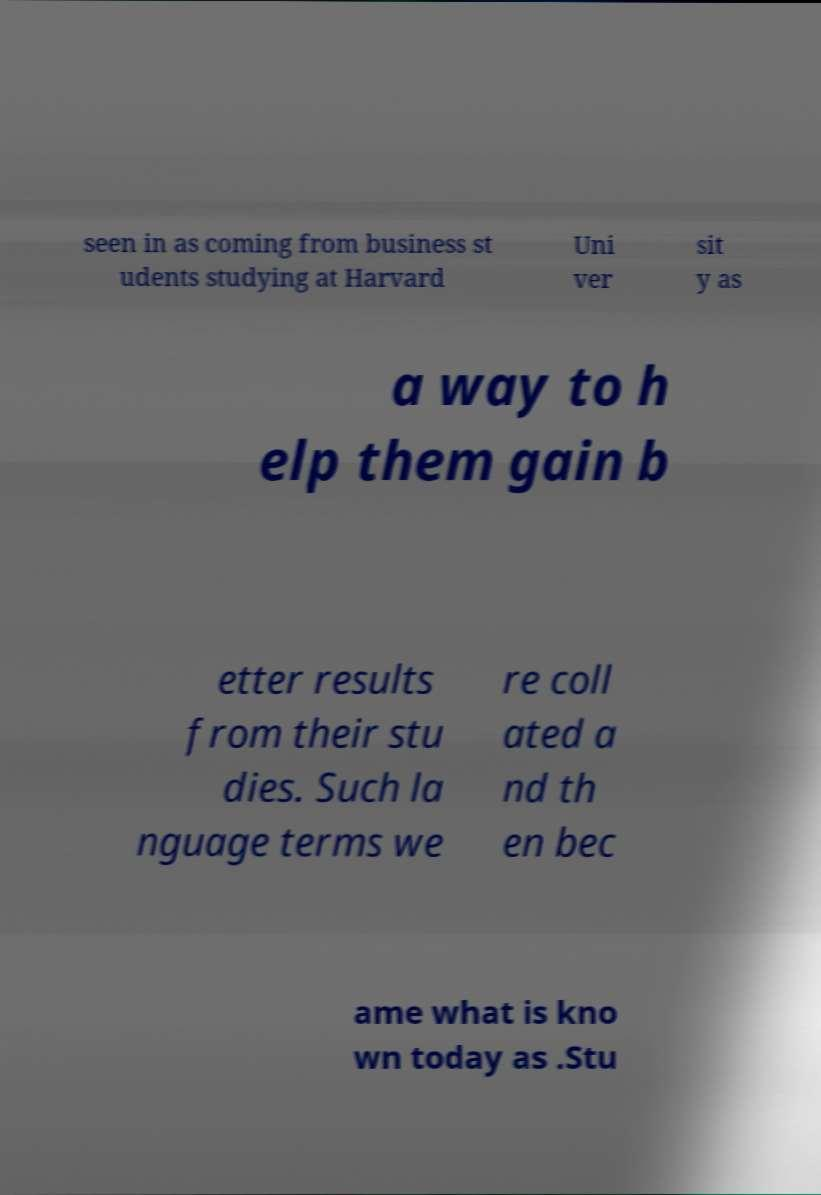Can you read and provide the text displayed in the image?This photo seems to have some interesting text. Can you extract and type it out for me? seen in as coming from business st udents studying at Harvard Uni ver sit y as a way to h elp them gain b etter results from their stu dies. Such la nguage terms we re coll ated a nd th en bec ame what is kno wn today as .Stu 